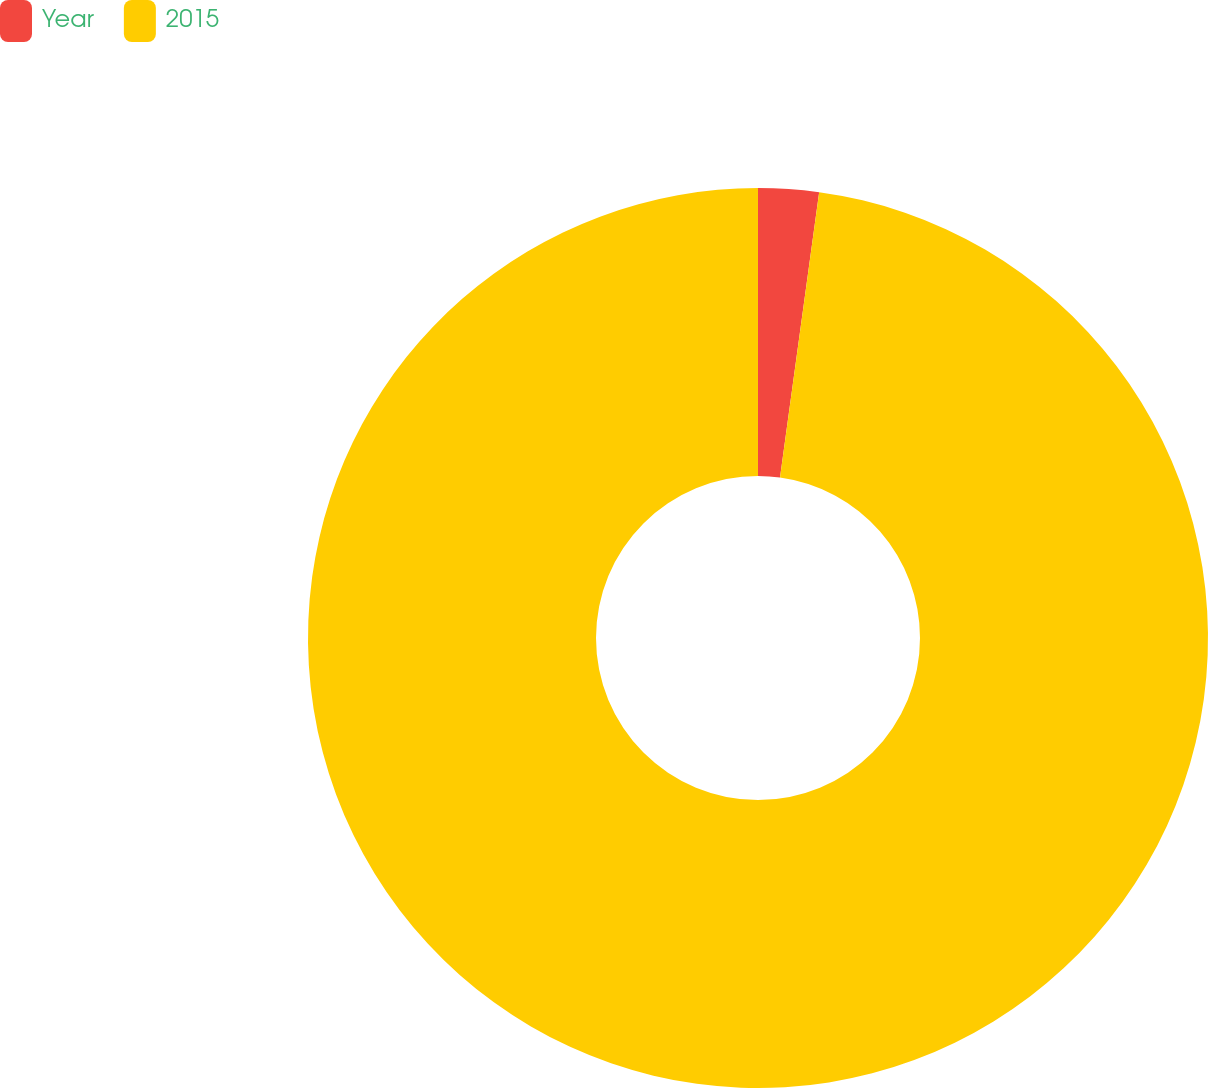Convert chart to OTSL. <chart><loc_0><loc_0><loc_500><loc_500><pie_chart><fcel>Year<fcel>2015<nl><fcel>2.17%<fcel>97.83%<nl></chart> 